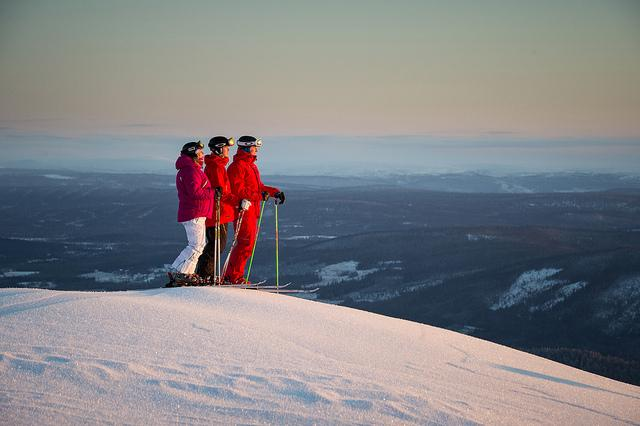What is the most likely time of day? Please explain your reasoning. sunset. The sun is low in the sky 